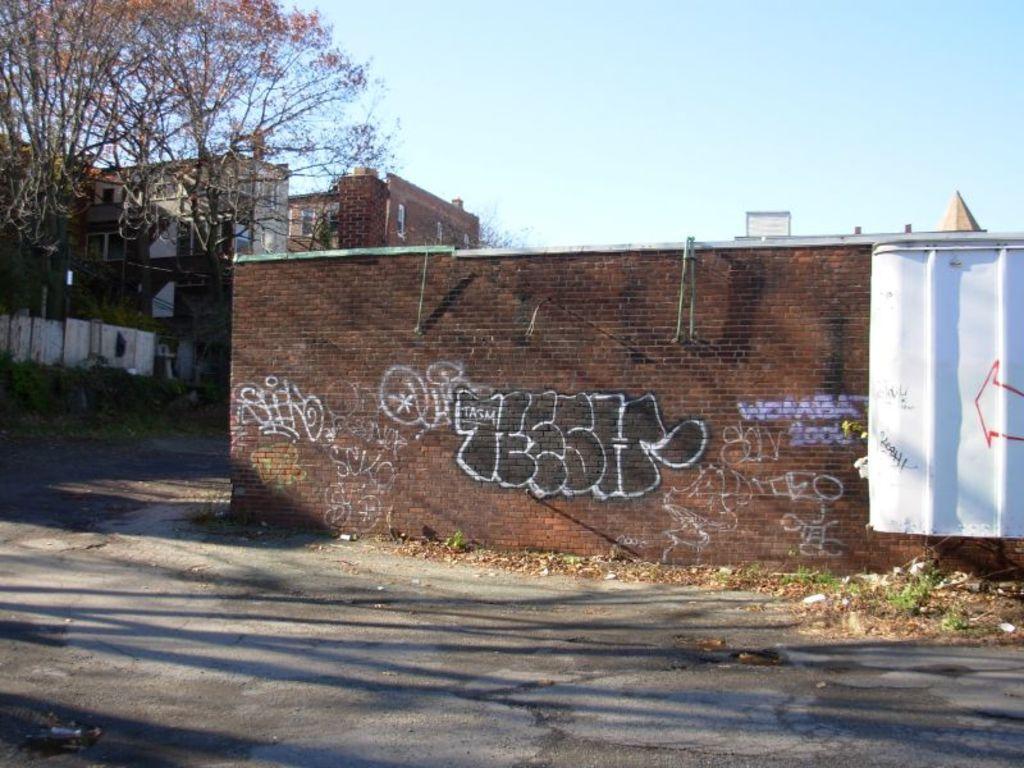Please provide a concise description of this image. In this image, we can see trees and buildings and at the bottom, there is road. 